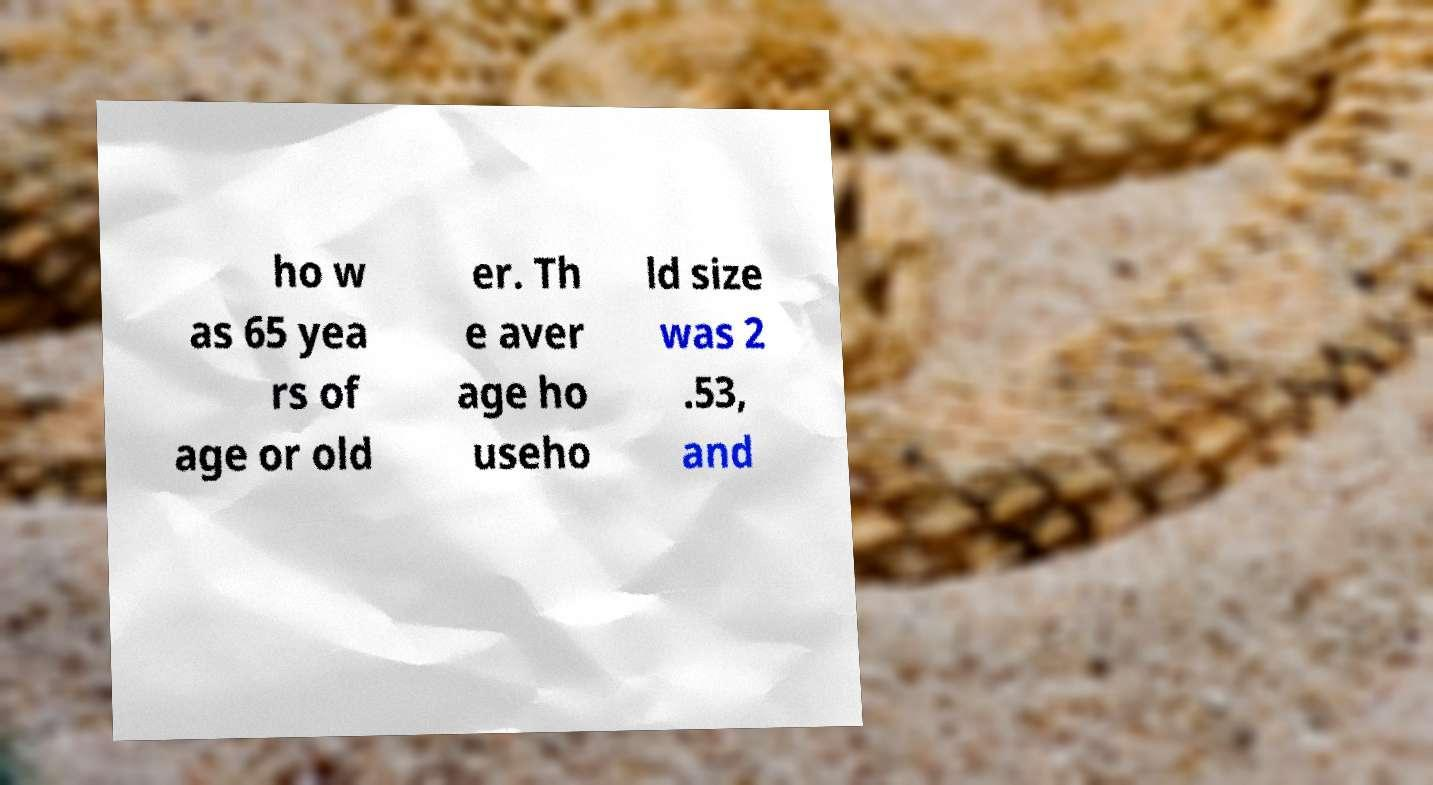I need the written content from this picture converted into text. Can you do that? ho w as 65 yea rs of age or old er. Th e aver age ho useho ld size was 2 .53, and 